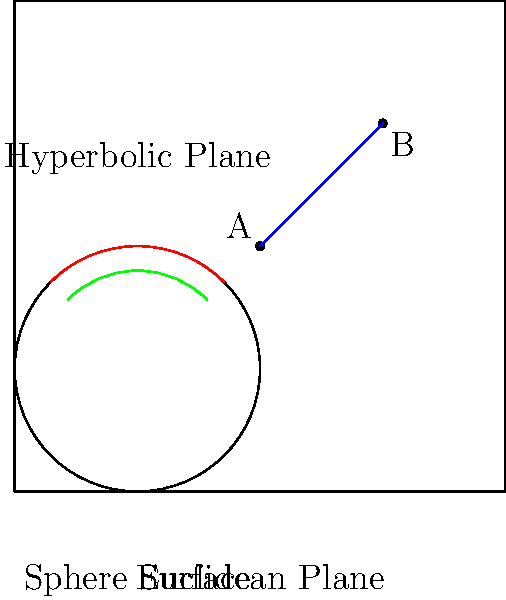Consider points A and B on different geometric surfaces as shown in the diagram. If the Euclidean distance between these points is 1.414 units, how would the distance between A and B compare on a spherical surface and in a hyperbolic plane? Explain the economic implications of these different distance measurements in the context of global trade routes. To answer this question, let's break it down step-by-step:

1. Euclidean distance:
   The Euclidean distance is given as 1.414 units, which is approximately $\sqrt{2}$. This is the straight-line distance between A and B on a flat plane.

2. Spherical distance:
   On a spherical surface, the distance between two points is measured along the great circle arc connecting them. This distance is always greater than or equal to the Euclidean distance. The exact measure depends on the sphere's radius, but it will be larger than 1.414 units.

3. Hyperbolic distance:
   In a hyperbolic plane, distances are measured along geodesics, which appear curved in the Poincaré disk model shown. The hyperbolic distance between two points is always greater than the Euclidean distance between the same points.

4. Comparison:
   Spherical distance > Euclidean distance
   Hyperbolic distance > Euclidean distance

5. Economic implications for global trade routes:

   a) Shipping and transportation costs: The actual distance traveled on the Earth's surface (which is roughly spherical) is greater than what appears on a flat map. This affects fuel consumption, time, and overall shipping costs.

   b) Route optimization: The shortest path between two points on a sphere (great circle route) is different from a straight line on a flat map. This impacts the design of efficient trade routes and flight paths.

   c) Market access: The concept of distance in economic geography affects market potential and access. Non-Euclidean geometries can provide more accurate models of economic interactions across curved spaces.

   d) Infrastructure planning: When planning global infrastructure like undersea cables or pipelines, understanding geodesic distances is crucial for accurate cost estimation and engineering.

   e) Trade agreements and economic zones: The perception of distance and proximity can influence regional economic cooperation and trade bloc formation.

   f) Location theory: Non-Euclidean distances can refine models of firm location, market areas, and spatial competition in global markets.

Understanding these geometric concepts allows economists to develop more accurate models of international trade, spatial economics, and global market interactions, leading to better-informed policy decisions and business strategies.
Answer: Spherical and hyperbolic distances > Euclidean distance; impacts trade route efficiency, shipping costs, and economic geography models. 